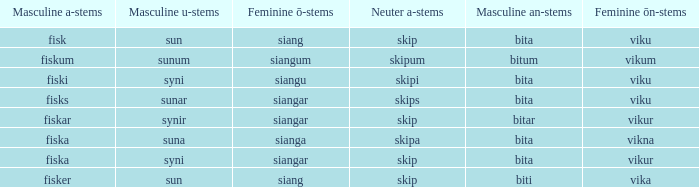What is the an-stem for the word which has an ö-stems of siangar and an u-stem ending of syni? Bita. 